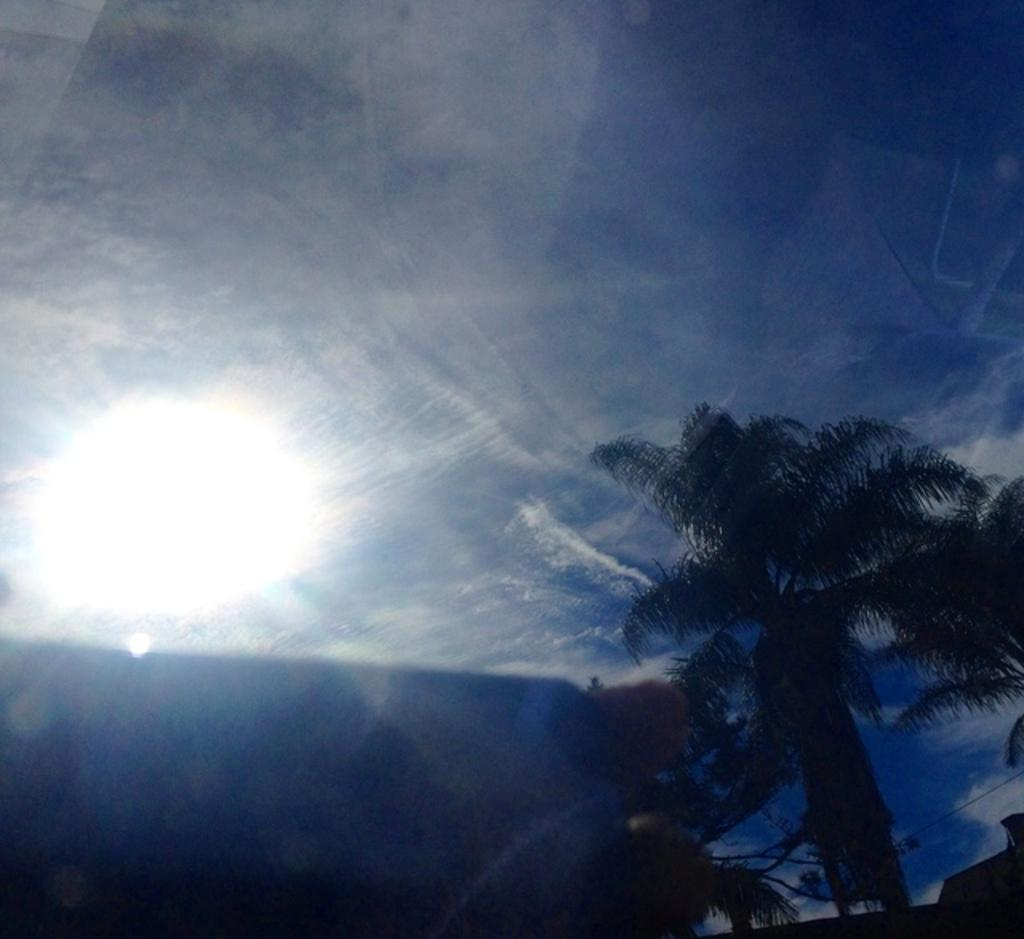What type of vegetation is present at the bottom of the image? There are trees at the bottom of the image. What can be seen in the background of the image? The sky is visible in the background of the image. Can you describe the lighting on the left side of the image? There appears to be sunlight on the left side of the image. What type of work is being done by the trees in the image? The trees are not performing any work in the image; they are simply standing as vegetation. How does the love between the trees manifest in the image? There is no indication of love between the trees in the image; they are not sentient beings capable of love. 